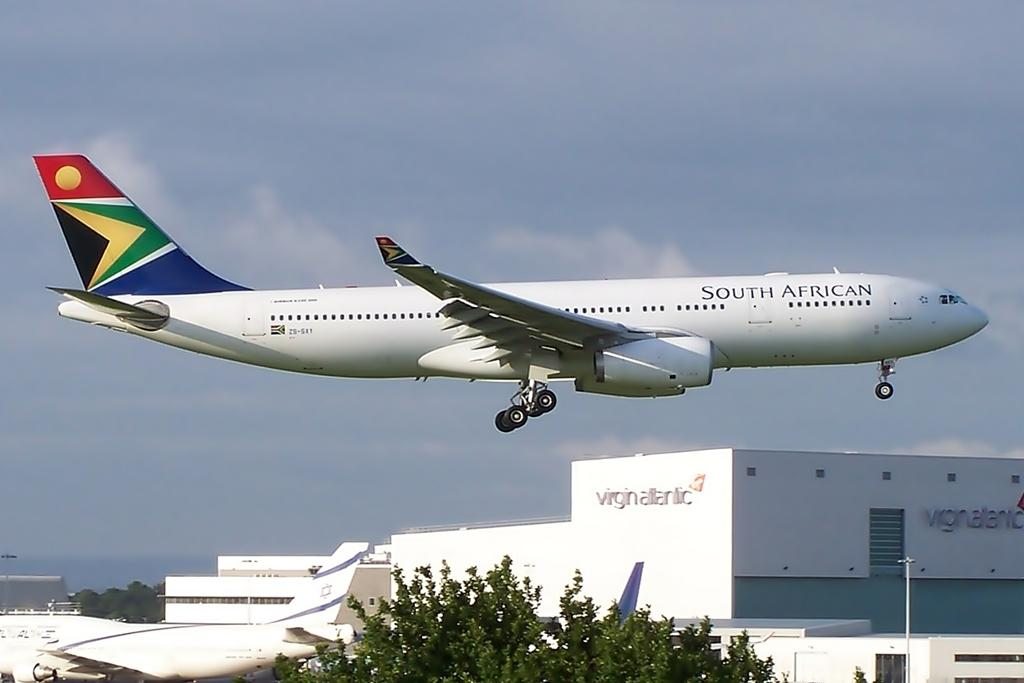<image>
Share a concise interpretation of the image provided. a view of South African airways airplane ready to land 